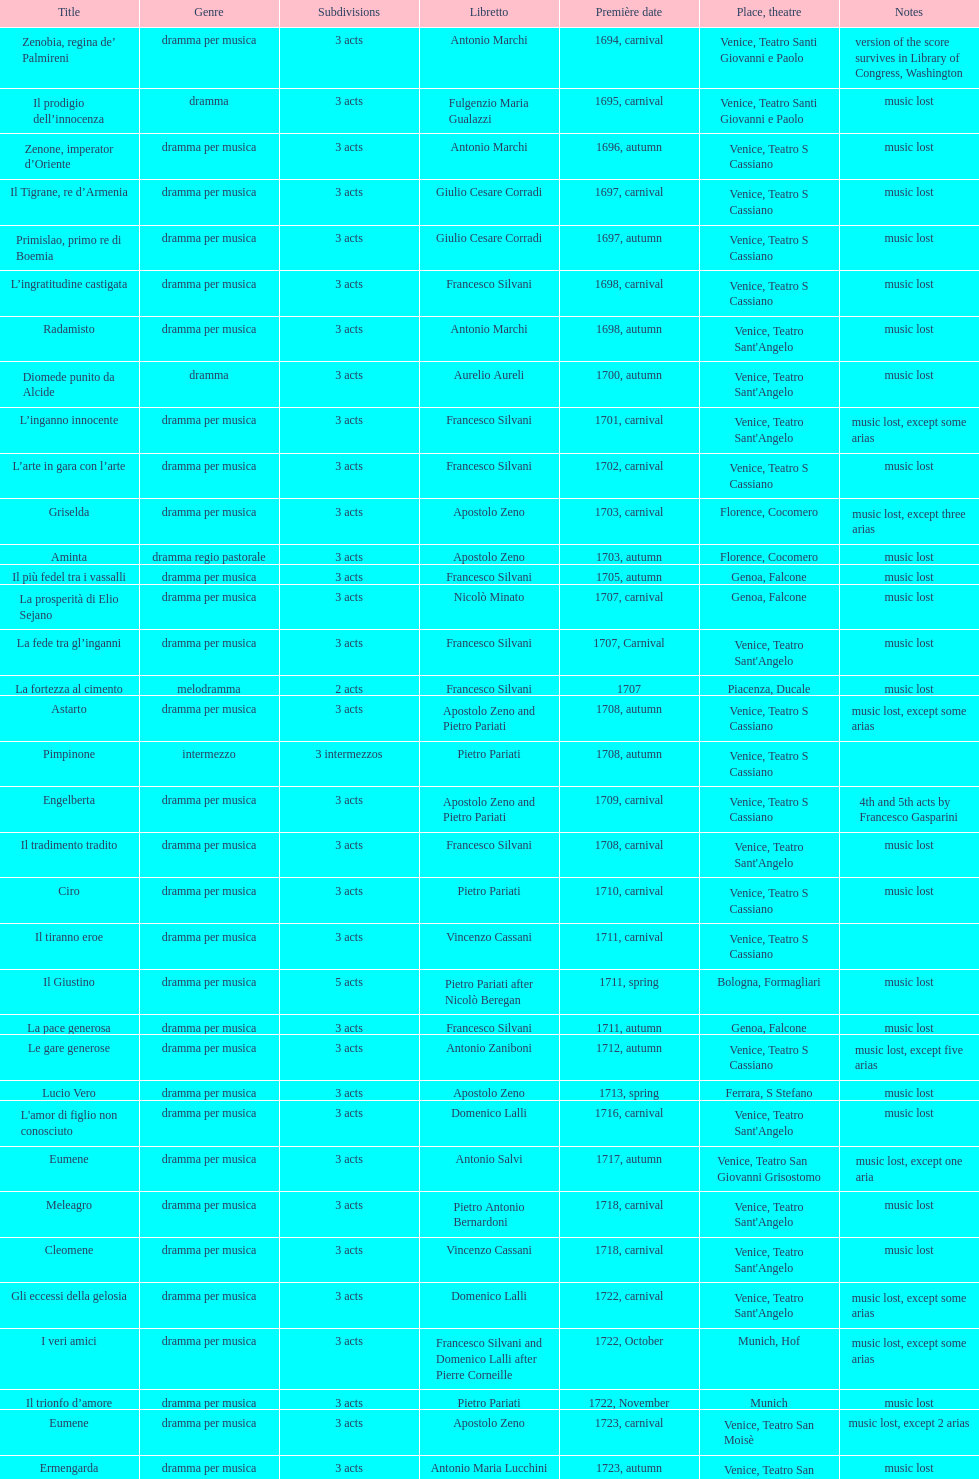What was the earlier title launched? Diomede punito da Alcide. 